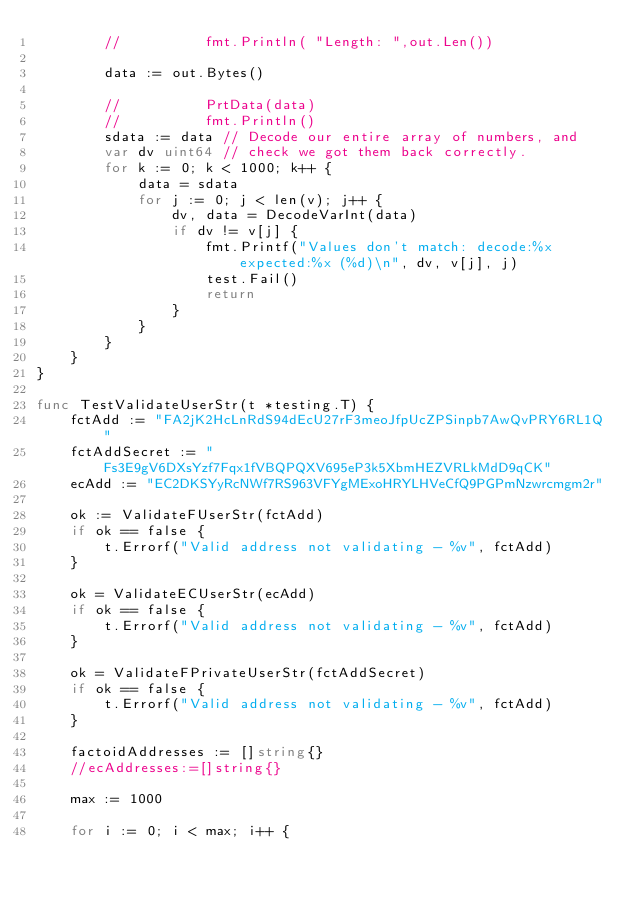<code> <loc_0><loc_0><loc_500><loc_500><_Go_>		//          fmt.Println( "Length: ",out.Len())

		data := out.Bytes()

		//          PrtData(data)
		//          fmt.Println()
		sdata := data // Decode our entire array of numbers, and
		var dv uint64 // check we got them back correctly.
		for k := 0; k < 1000; k++ {
			data = sdata
			for j := 0; j < len(v); j++ {
				dv, data = DecodeVarInt(data)
				if dv != v[j] {
					fmt.Printf("Values don't match: decode:%x expected:%x (%d)\n", dv, v[j], j)
					test.Fail()
					return
				}
			}
		}
	}
}

func TestValidateUserStr(t *testing.T) {
	fctAdd := "FA2jK2HcLnRdS94dEcU27rF3meoJfpUcZPSinpb7AwQvPRY6RL1Q"
	fctAddSecret := "Fs3E9gV6DXsYzf7Fqx1fVBQPQXV695eP3k5XbmHEZVRLkMdD9qCK"
	ecAdd := "EC2DKSYyRcNWf7RS963VFYgMExoHRYLHVeCfQ9PGPmNzwrcmgm2r"

	ok := ValidateFUserStr(fctAdd)
	if ok == false {
		t.Errorf("Valid address not validating - %v", fctAdd)
	}

	ok = ValidateECUserStr(ecAdd)
	if ok == false {
		t.Errorf("Valid address not validating - %v", fctAdd)
	}

	ok = ValidateFPrivateUserStr(fctAddSecret)
	if ok == false {
		t.Errorf("Valid address not validating - %v", fctAdd)
	}

	factoidAddresses := []string{}
	//ecAddresses:=[]string{}

	max := 1000

	for i := 0; i < max; i++ {</code> 